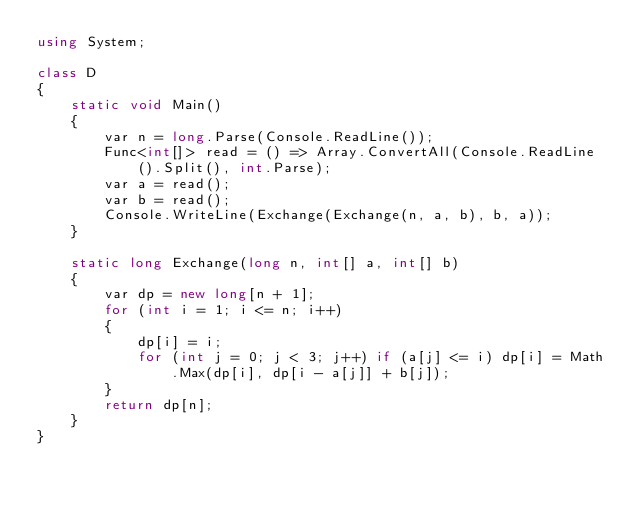Convert code to text. <code><loc_0><loc_0><loc_500><loc_500><_C#_>using System;

class D
{
	static void Main()
	{
		var n = long.Parse(Console.ReadLine());
		Func<int[]> read = () => Array.ConvertAll(Console.ReadLine().Split(), int.Parse);
		var a = read();
		var b = read();
		Console.WriteLine(Exchange(Exchange(n, a, b), b, a));
	}

	static long Exchange(long n, int[] a, int[] b)
	{
		var dp = new long[n + 1];
		for (int i = 1; i <= n; i++)
		{
			dp[i] = i;
			for (int j = 0; j < 3; j++) if (a[j] <= i) dp[i] = Math.Max(dp[i], dp[i - a[j]] + b[j]);
		}
		return dp[n];
	}
}
</code> 